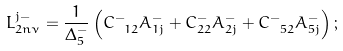<formula> <loc_0><loc_0><loc_500><loc_500>L _ { 2 n \nu } ^ { j - } = \frac { 1 } { \Delta _ { 5 } ^ { - } } \left ( C _ { \ 1 2 } ^ { - } A _ { 1 j } ^ { - } + C _ { 2 2 } ^ { - } A _ { 2 j } ^ { - } + C _ { \ 5 2 } ^ { - } A _ { 5 j } ^ { - } \right ) ;</formula> 